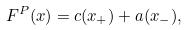<formula> <loc_0><loc_0><loc_500><loc_500>F ^ { P } ( x ) = c ( x _ { + } ) + a ( x _ { - } ) ,</formula> 